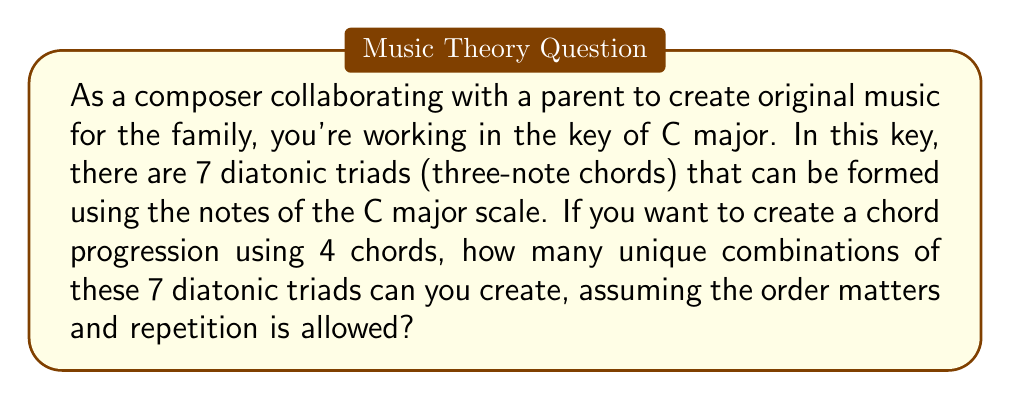Help me with this question. Let's approach this step-by-step:

1) First, we need to understand what we're dealing with:
   - We have 7 diatonic triads in the key of C major
   - We're creating a progression of 4 chords
   - The order matters (e.g., C-F-G-Am is different from F-C-Am-G)
   - Repetition is allowed (e.g., C-F-C-G is a valid progression)

2) This scenario is a classic example of a permutation with repetition.

3) The formula for permutations with repetition is:

   $$ n^r $$

   Where:
   $n$ = number of items to choose from
   $r$ = number of items being chosen

4) In our case:
   $n = 7$ (7 diatonic triads to choose from)
   $r = 4$ (we're choosing 4 chords for our progression)

5) Plugging these numbers into our formula:

   $$ 7^4 = 2401 $$

Therefore, there are 2401 possible unique chord progressions that can be created using 4 chords from the 7 diatonic triads in the key of C major.
Answer: 2401 possible chord combinations 